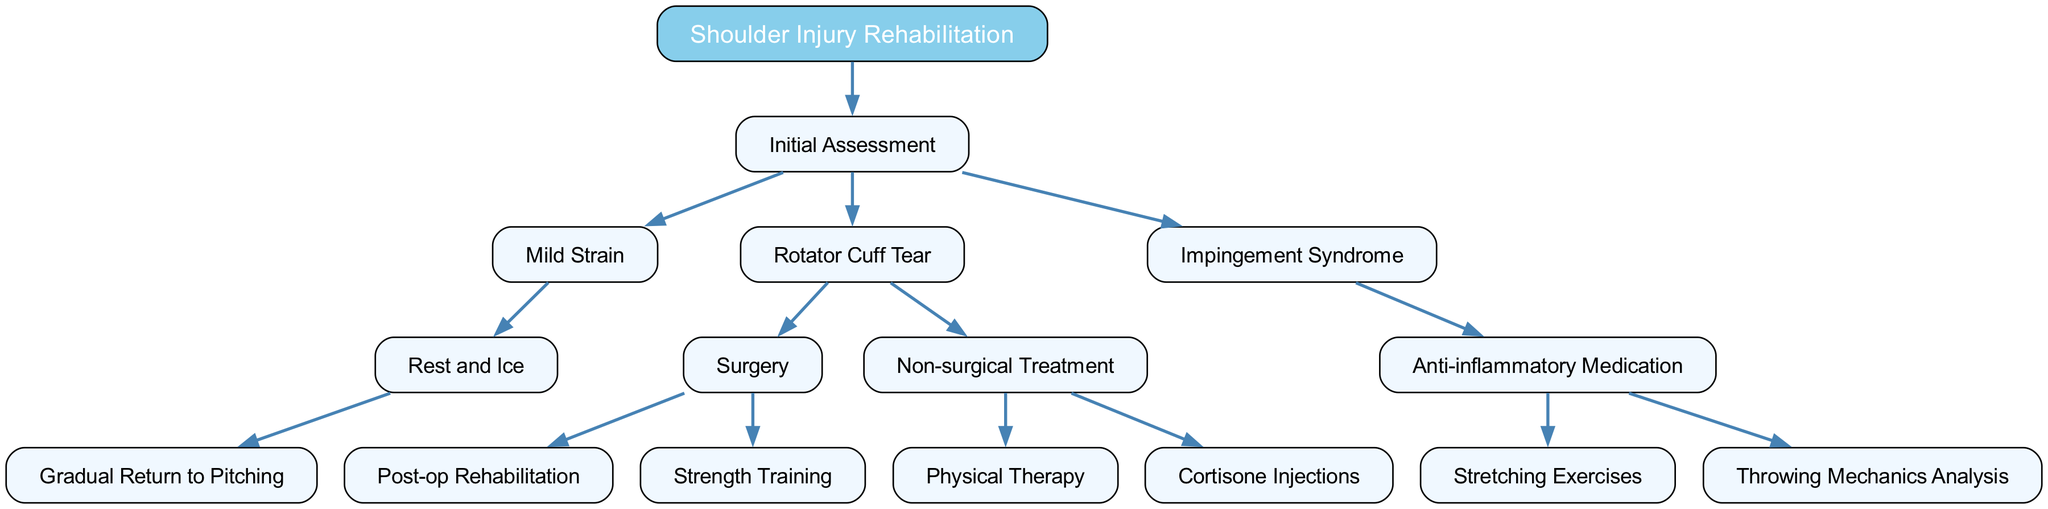What is the root of the decision tree? The root of the decision tree, as indicated in the diagram, is the starting point for all branches and it is labeled "Shoulder Injury Rehabilitation."
Answer: Shoulder Injury Rehabilitation How many treatment options are available for Rotator Cuff Tear? In the diagram, the "Rotator Cuff Tear" node splits into two treatment options: "Surgery" and "Non-surgical Treatment," indicating that there are two main pathways.
Answer: 2 What is the first step for a Mild Strain? Following the branches from "Mild Strain," the first step recommended is "Rest and Ice" before progressing to "Gradual Return to Pitching."
Answer: Rest and Ice What follow-up treatment follows Surgery for Rotator Cuff Tear? After selecting "Surgery" for the Rotator Cuff Tear, the diagram shows two subsequent steps; one of them is "Post-op Rehabilitation," which is typically the first follow-up treatment.
Answer: Post-op Rehabilitation Which treatment option is provided for Impingement Syndrome? The diagram shows that the treatment for Impingement Syndrome includes "Anti-inflammatory Medication," which leads to additional steps of "Stretching Exercises" and "Throwing Mechanics Analysis."
Answer: Anti-inflammatory Medication How many distinct conditions are assessed in the initial assessment? The initial assessment node has three branches labeled "Mild Strain," "Rotator Cuff Tear," and "Impingement Syndrome," indicating that there are three distinct conditions being assessed.
Answer: 3 What is the final step for Non-surgical Treatment of Rotator Cuff Tear? Following the "Non-surgical Treatment," the diagram outlines two potential treatments: "Physical Therapy" and "Cortisone Injections," noting there is no distinct final step but two alternative paths.
Answer: Physical Therapy or Cortisone Injections Which treatment option does not require surgery? The "Non-surgical Treatment" branch clearly indicates that there are options that do not involve a surgical procedure for treating Rotator Cuff Tear.
Answer: Non-surgical Treatment What is the secondary treatment after Anti-inflammatory Medication for Impingement Syndrome? After "Anti-inflammatory Medication," the diagram states the treatment options include "Stretching Exercises" and "Throwing Mechanics Analysis," indicating these are secondary treatments.
Answer: Stretching Exercises or Throwing Mechanics Analysis 